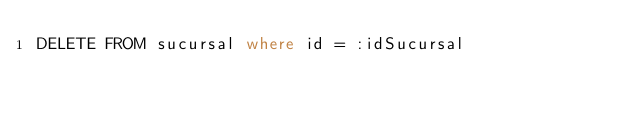<code> <loc_0><loc_0><loc_500><loc_500><_SQL_>DELETE FROM sucursal where id = :idSucursal</code> 